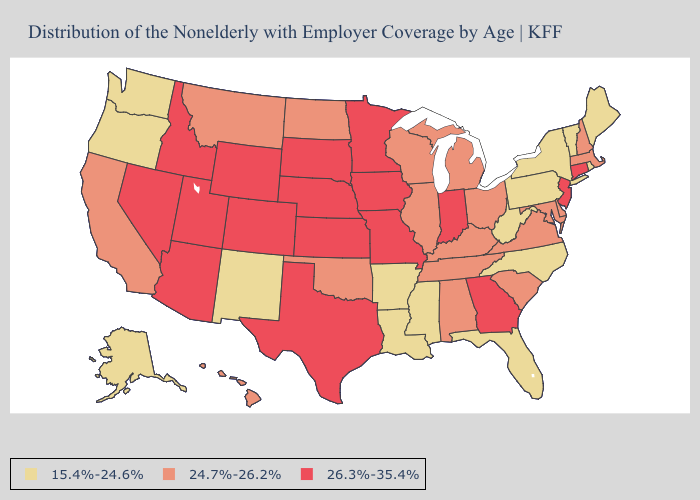Among the states that border Oklahoma , which have the lowest value?
Give a very brief answer. Arkansas, New Mexico. What is the highest value in the South ?
Quick response, please. 26.3%-35.4%. Which states hav the highest value in the South?
Write a very short answer. Georgia, Texas. What is the value of Oregon?
Give a very brief answer. 15.4%-24.6%. How many symbols are there in the legend?
Short answer required. 3. Name the states that have a value in the range 24.7%-26.2%?
Give a very brief answer. Alabama, California, Delaware, Hawaii, Illinois, Kentucky, Maryland, Massachusetts, Michigan, Montana, New Hampshire, North Dakota, Ohio, Oklahoma, South Carolina, Tennessee, Virginia, Wisconsin. Which states have the highest value in the USA?
Answer briefly. Arizona, Colorado, Connecticut, Georgia, Idaho, Indiana, Iowa, Kansas, Minnesota, Missouri, Nebraska, Nevada, New Jersey, South Dakota, Texas, Utah, Wyoming. What is the value of Utah?
Concise answer only. 26.3%-35.4%. Name the states that have a value in the range 24.7%-26.2%?
Write a very short answer. Alabama, California, Delaware, Hawaii, Illinois, Kentucky, Maryland, Massachusetts, Michigan, Montana, New Hampshire, North Dakota, Ohio, Oklahoma, South Carolina, Tennessee, Virginia, Wisconsin. Which states hav the highest value in the MidWest?
Concise answer only. Indiana, Iowa, Kansas, Minnesota, Missouri, Nebraska, South Dakota. Name the states that have a value in the range 24.7%-26.2%?
Write a very short answer. Alabama, California, Delaware, Hawaii, Illinois, Kentucky, Maryland, Massachusetts, Michigan, Montana, New Hampshire, North Dakota, Ohio, Oklahoma, South Carolina, Tennessee, Virginia, Wisconsin. What is the value of North Carolina?
Keep it brief. 15.4%-24.6%. Does Rhode Island have the same value as Connecticut?
Be succinct. No. Among the states that border Mississippi , does Tennessee have the lowest value?
Write a very short answer. No. 